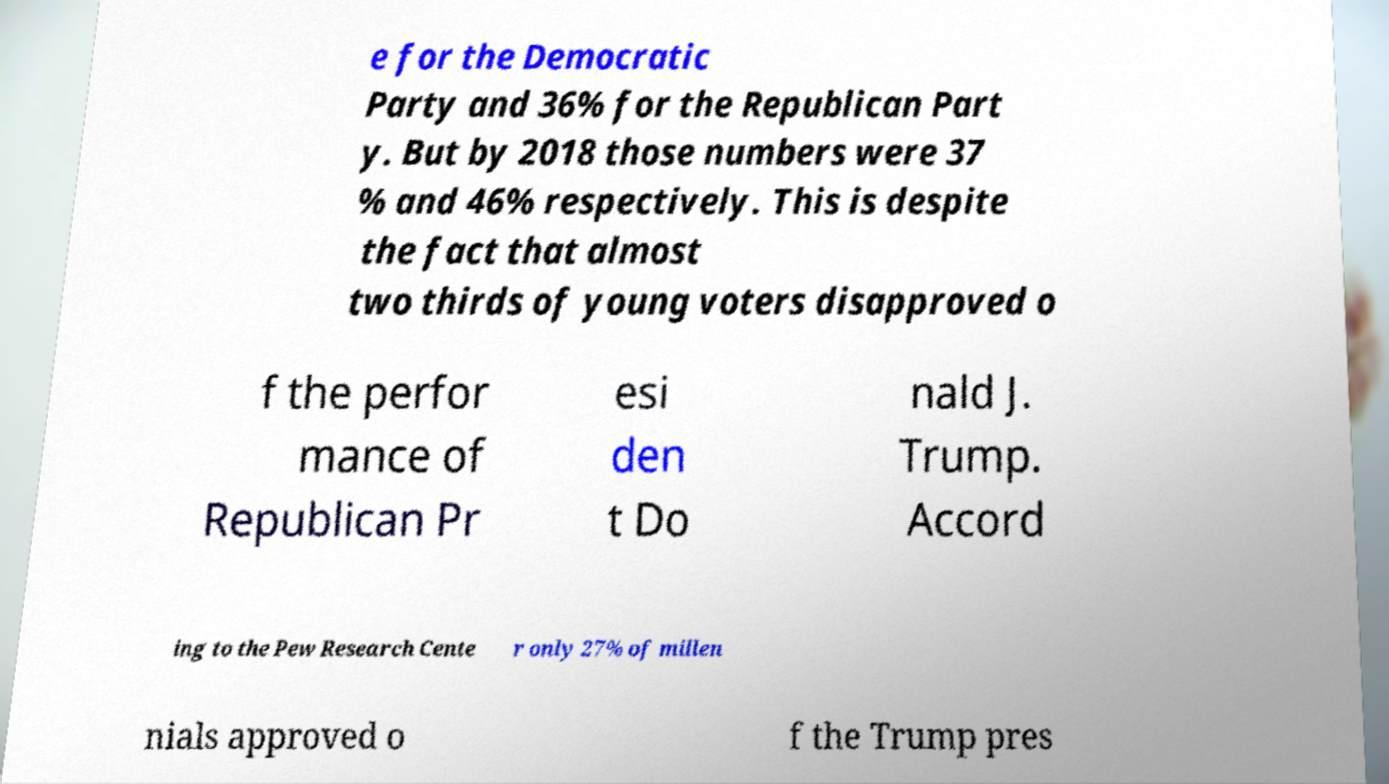I need the written content from this picture converted into text. Can you do that? e for the Democratic Party and 36% for the Republican Part y. But by 2018 those numbers were 37 % and 46% respectively. This is despite the fact that almost two thirds of young voters disapproved o f the perfor mance of Republican Pr esi den t Do nald J. Trump. Accord ing to the Pew Research Cente r only 27% of millen nials approved o f the Trump pres 